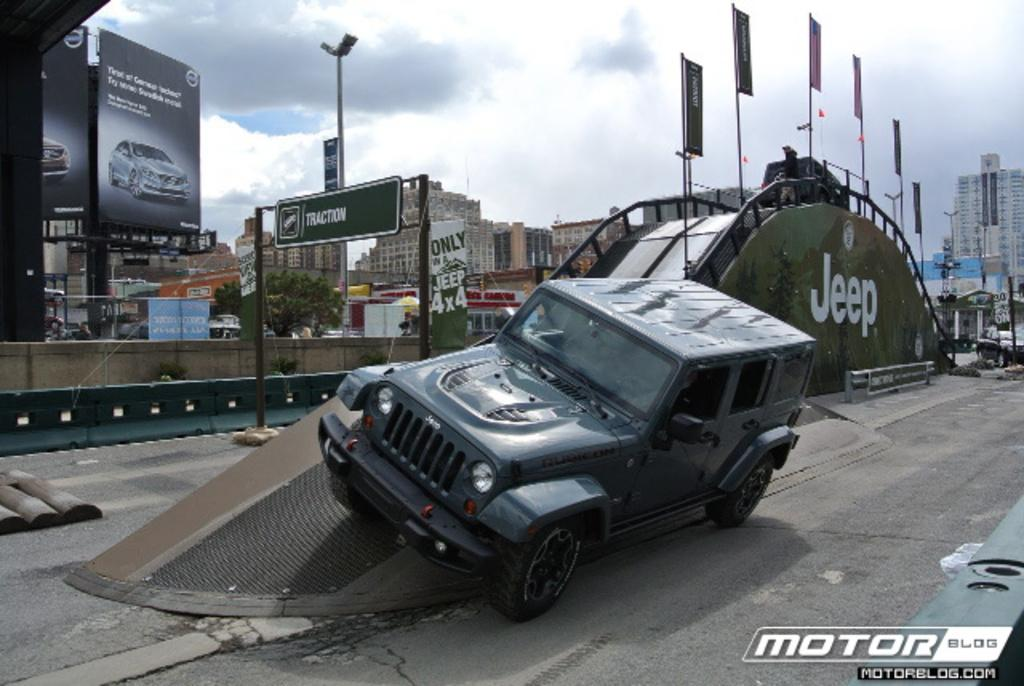What is the weather like in the image? The sky in the image is cloudy. What type of vegetation can be seen in the image? There is a tree in the image. What mode of transportation is present in the image? There is a vehicle in the image. What type of signage is visible in the image? There are advertising boards in the image. What type of surface is visible in the image? There is a road in the image. What type of structures are present in the image? There are many buildings in the image. Can you see a rod being used to catch fish in the image? There is no rod or fishing activity present in the image. What type of frog can be seen sitting on the advertising board in the image? There is no frog present in the image; only the vehicle, tree, buildings, and advertising boards are visible. 